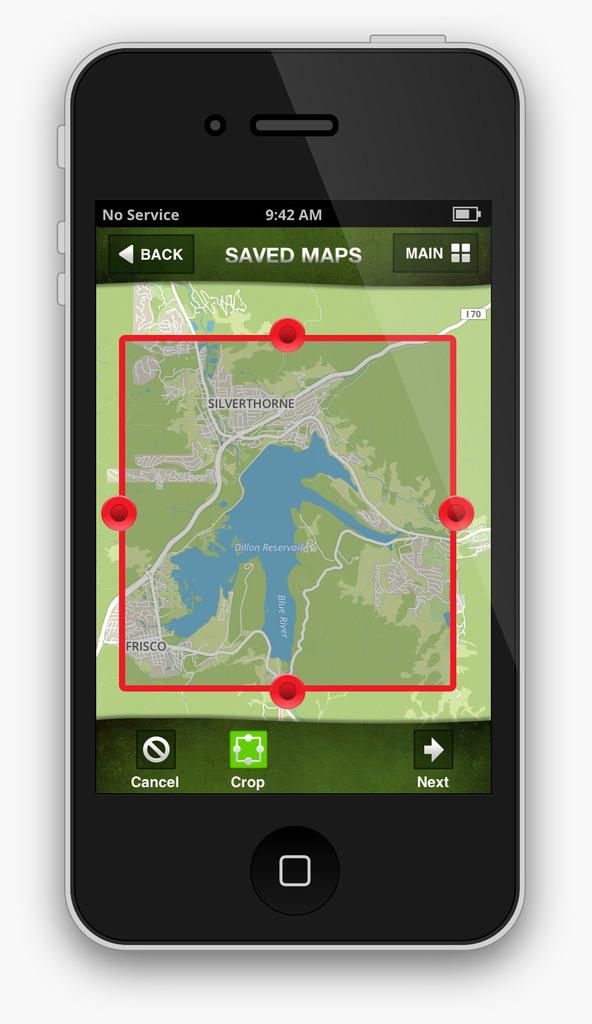Is the time on the phone in the morning?
Offer a terse response. Yes. What is this a map of?
Offer a very short reply. Silverthorne. 